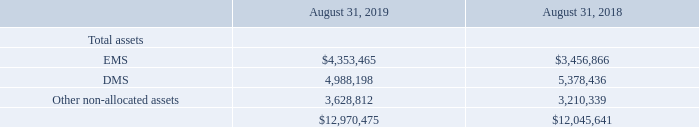Segment Data
Operating segments are defined as components of an enterprise that engage in business activities from which they may earn revenues and incur expenses; for which separate financial information is available; and whose operating results are regularly reviewed by the chief operating decision maker to assess the performance
of the individual segment and make decisions about resources to be allocated to the segment.
The Company derives its revenue from providing comprehensive electronics design, production and product management services. The chief operating decision maker evaluates performance and allocates resources on a segment basis. The Company’s operating segments consist of two segments – EMS and DMS, which are also the Company’s reportable segments. The segments are organized based on the economic profiles of the services performed, including manufacturing capabilities, market strategy, margins, return on capital and risk profiles.
The EMS segment is focused around leveraging IT, supply chain design and engineering, technologies largely centered on core electronics, utilizing the Company’s large scale manufacturing infrastructure and the ability to serve a broad range of end markets. The EMS segment is a high volume business that produces products at a quicker rate (i.e. cycle time) and in larger quantities and includes customers primarily in the automotive and transportation, capital equipment, cloud, computing and storage, defense and aerospace, industrial and energy, networking and telecommunications, print and retail, and smart home and appliances industries.
The DMS segment is focused on providing engineering solutions, with an emphasis on material sciences, technologies and healthcare. The DMS segment includes customers primarily in the edge devices and accessories, healthcare, mobility and packaging industries.
Net revenue for the operating segments is attributed to the segment in which the service is performed. An operating segment’s performance is evaluated based on its pre-tax operating contribution, or segment income. Segment income is defined as net revenue less cost of revenue, segment selling, general and administrative expenses, segment research and development expenses and an allocation of corporate manufacturing expenses and selling, general and administrative expenses. Segment income does not include amortization of intangibles, stock-based compensation expense and related charges, restructuring and related charges, distressed customer charges, acquisition and integration charges, loss on disposal of subsidiaries, settlement of receivables and related charges, impairment of notes receivable and related charges, restructuring of securities loss, goodwill impairment charges, business interruption and impairment charges, net, income (loss) from discontinued operations, gain (loss) on sale of discontinued operations, other expense, interest income, interest expense, income tax expense or adjustment for net income (loss) attributable to noncontrolling interests.
Total segment assets are defined as accounts receivable, inventories, net, customer-related property, plant and equipment, intangible assets net of accumulated amortization and goodwill. All other non-segment assets are reviewed on a global basis by management. Transactions between operating segments are generally recorded at amounts that approximate those at which we would transact with third parties.
The following tables set forth operating segment information (in thousands):
How are total segment assets defined? Accounts receivable, inventories, net, customer-related property, plant and equipment, intangible assets net of accumulated amortization and goodwill. What was the amount of Other non-allocated assets in 2019? 
Answer scale should be: thousand. 3,628,812. What was the amount of EMS Assets in 2019?
Answer scale should be: thousand. $4,353,465. How many assets in 2019 exceeded $4,000,000 thousand? EMS##DMS
Answer: 2. What was the change in total DMS assets between 2018 and 2019?
Answer scale should be: thousand. 4,988,198-5,378,436
Answer: -390238. What was the percentage change in total assets between 2018 and 2019?
Answer scale should be: percent. ($12,970,475-$12,045,641)/$12,045,641
Answer: 7.68. 